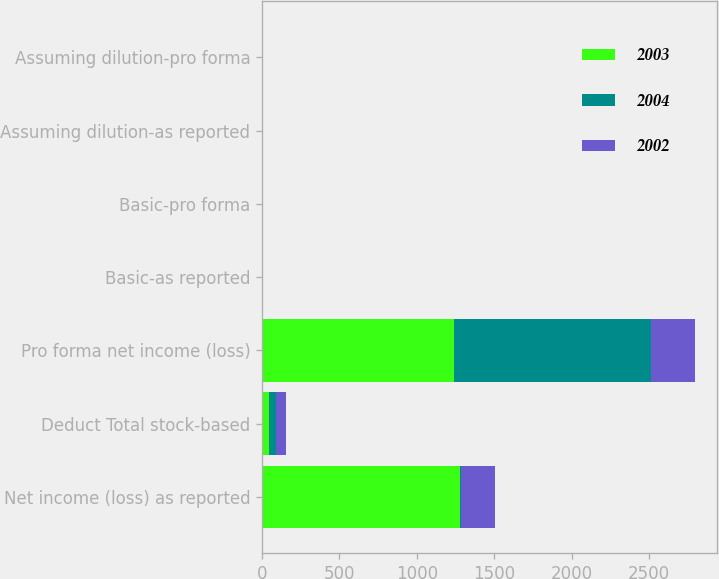<chart> <loc_0><loc_0><loc_500><loc_500><stacked_bar_chart><ecel><fcel>Net income (loss) as reported<fcel>Deduct Total stock-based<fcel>Pro forma net income (loss)<fcel>Basic-as reported<fcel>Basic-pro forma<fcel>Assuming dilution-as reported<fcel>Assuming dilution-pro forma<nl><fcel>2003<fcel>1281<fcel>42<fcel>1239<fcel>1.49<fcel>1.44<fcel>1.49<fcel>1.44<nl><fcel>2004<fcel>1.515<fcel>48<fcel>1276<fcel>1.54<fcel>1.48<fcel>1.54<fcel>1.48<nl><fcel>2002<fcel>220<fcel>64<fcel>284<fcel>0.27<fcel>0.35<fcel>0.27<fcel>0.35<nl></chart> 